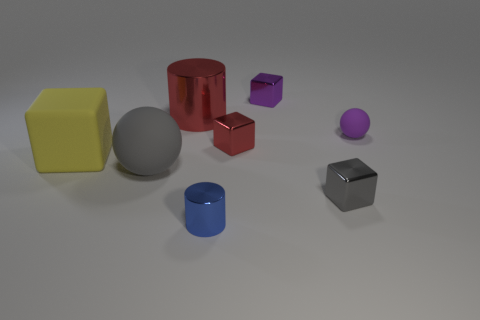What shape is the gray rubber thing that is the same size as the rubber block?
Offer a very short reply. Sphere. Are there any big metallic things that have the same shape as the tiny matte thing?
Your answer should be compact. No. Do the purple sphere and the cube that is in front of the yellow rubber thing have the same material?
Give a very brief answer. No. What color is the metal cylinder that is in front of the tiny purple thing that is in front of the small purple object that is behind the tiny purple rubber thing?
Your answer should be very brief. Blue. There is a red cylinder that is the same size as the yellow thing; what is it made of?
Offer a very short reply. Metal. What number of gray objects are made of the same material as the gray ball?
Your response must be concise. 0. There is a purple thing that is behind the tiny purple rubber sphere; is it the same size as the metal cylinder in front of the purple rubber thing?
Offer a very short reply. Yes. The big thing behind the red block is what color?
Offer a very short reply. Red. What number of small shiny objects are the same color as the large shiny thing?
Your answer should be very brief. 1. There is a blue shiny object; is its size the same as the cube in front of the gray matte object?
Your response must be concise. Yes. 